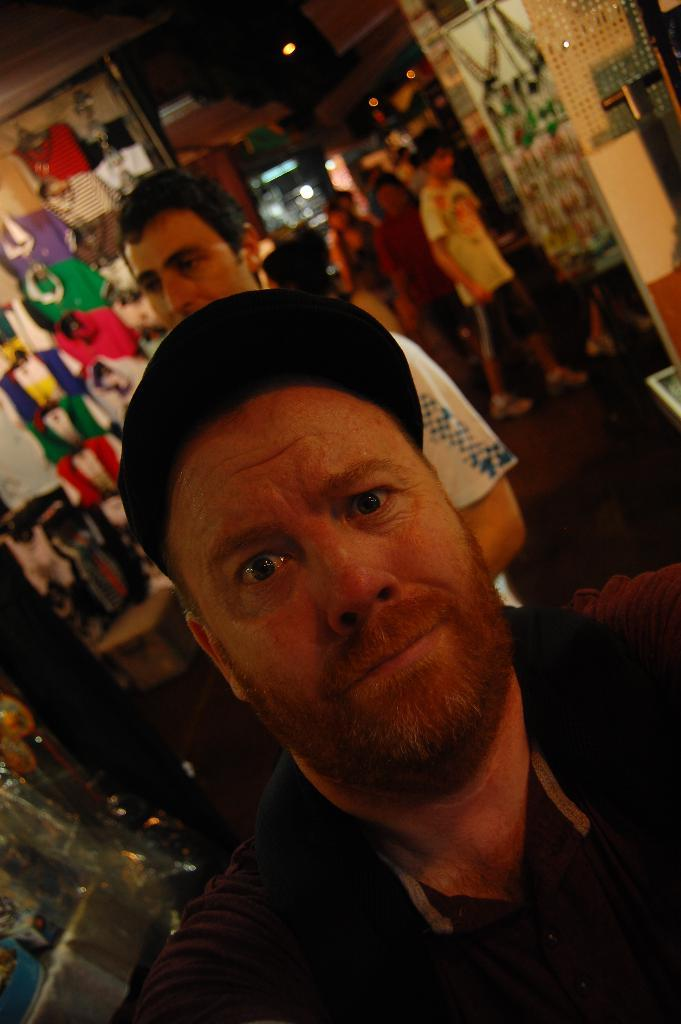What can be seen in the image? There is a group of people in the image, with a man in the middle. What is the man wearing on his head? The man is wearing a cap. What is visible behind the man? There are clothes visible behind the man. What can be seen in the image that provides illumination? There are lights visible in the image. Can you describe any other objects or features in the image? There are other unspecified things visible in the image. What type of linen is being used by the man in the image? There is no linen visible in the image, and the man is not using any linen. Is the man playing basketball in the image? There is no basketball or any indication of basketball-related activities in the image. 